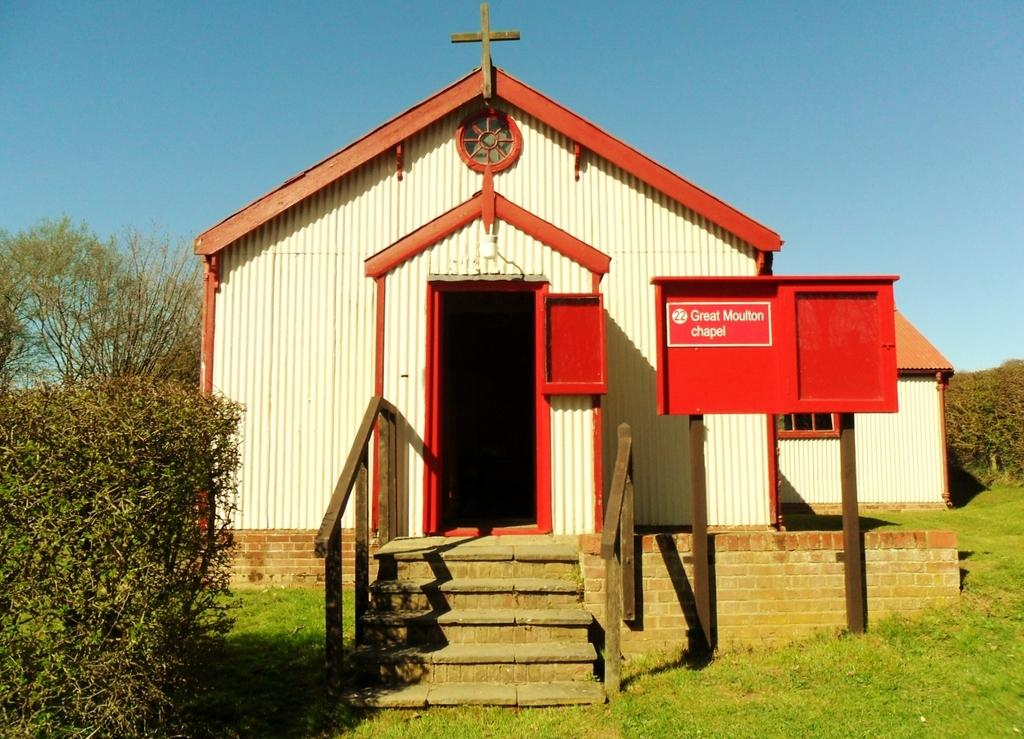What type of vegetation can be seen in the image? There are plants, trees, and grass in the image. Are there any structures visible in the image? Yes, there are houses in the image. What part of the natural environment is visible in the image? The sky is visible in the image. What type of picture is hanging on the wall in the image? There is no mention of a picture hanging on the wall in the image, as the facts provided only mention plants, trees, grass, houses, and the sky. 